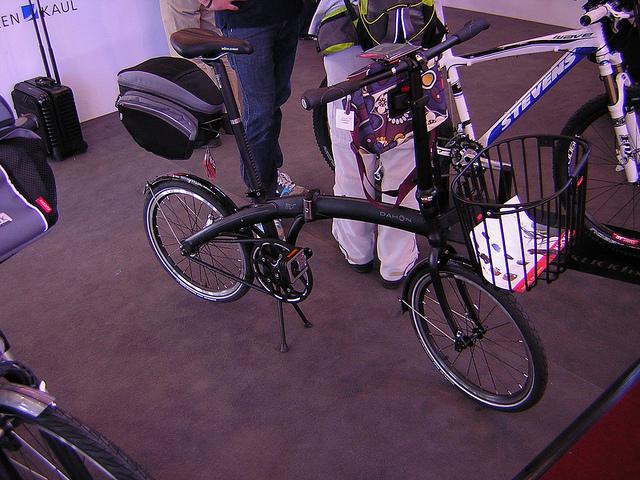What keeps the bike upright?
Be succinct. Kickstand. What is the purpose of the object in the basket?
Answer briefly. Give information. Does this bike have storage?
Short answer required. Yes. Where is this?
Give a very brief answer. Airport. How many rackets are in his backpack?
Quick response, please. 0. What kind of bike is this?
Concise answer only. Road. 